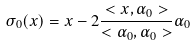<formula> <loc_0><loc_0><loc_500><loc_500>\sigma _ { 0 } ( x ) = x - 2 \frac { < x , \alpha _ { 0 } > } { < \alpha _ { 0 } , \alpha _ { 0 } > } \alpha _ { 0 }</formula> 